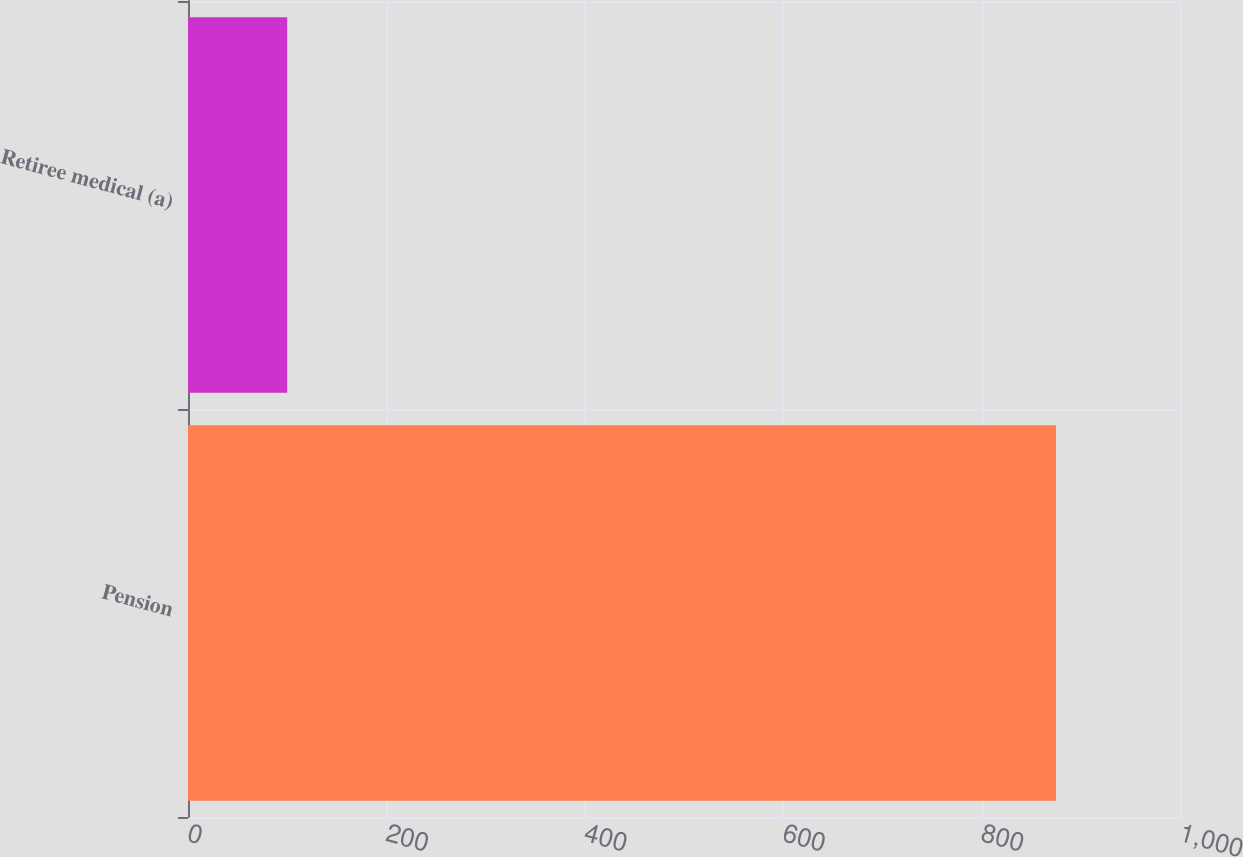Convert chart to OTSL. <chart><loc_0><loc_0><loc_500><loc_500><bar_chart><fcel>Pension<fcel>Retiree medical (a)<nl><fcel>875<fcel>100<nl></chart> 